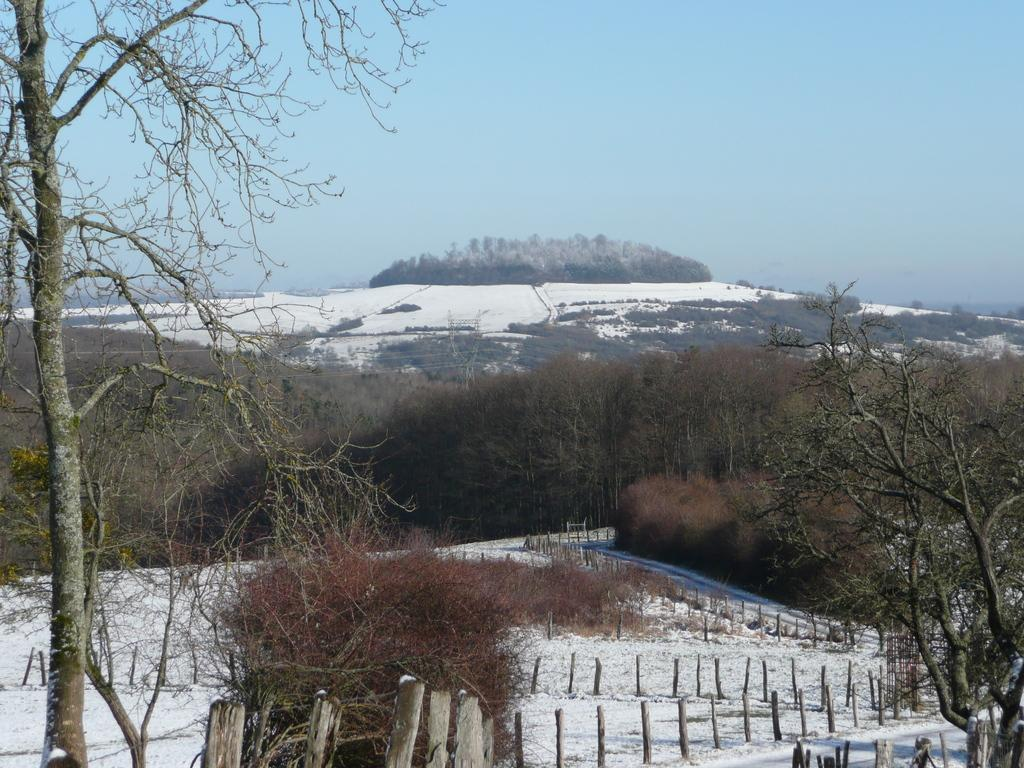What type of vegetation is visible in the image? There are many trees in the image. What is visible at the top of the image? The sky is visible at the top of the image. What objects are present on the ground in the image? Wooden sticks are present on the ground. What is the weather like in the image? There is snow in the image, indicating a cold or wintery environment. How many buttons can be seen on the trees in the image? There are no buttons present on the trees in the image; they are natural vegetation. 